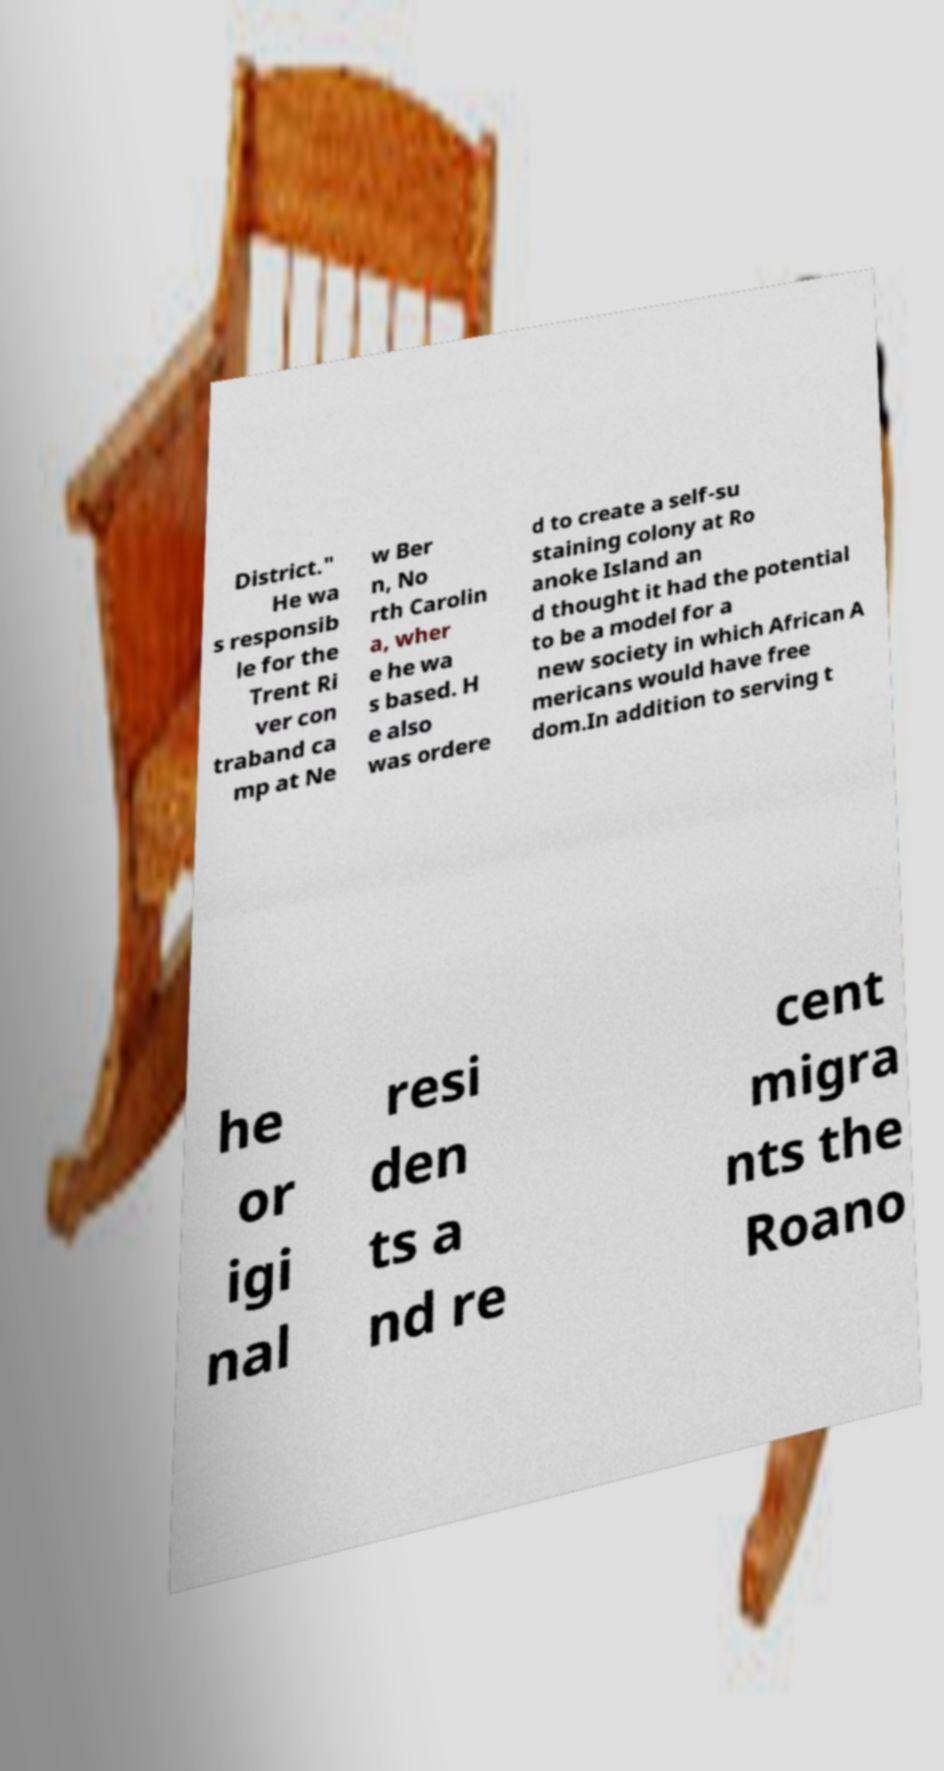Could you assist in decoding the text presented in this image and type it out clearly? District." He wa s responsib le for the Trent Ri ver con traband ca mp at Ne w Ber n, No rth Carolin a, wher e he wa s based. H e also was ordere d to create a self-su staining colony at Ro anoke Island an d thought it had the potential to be a model for a new society in which African A mericans would have free dom.In addition to serving t he or igi nal resi den ts a nd re cent migra nts the Roano 